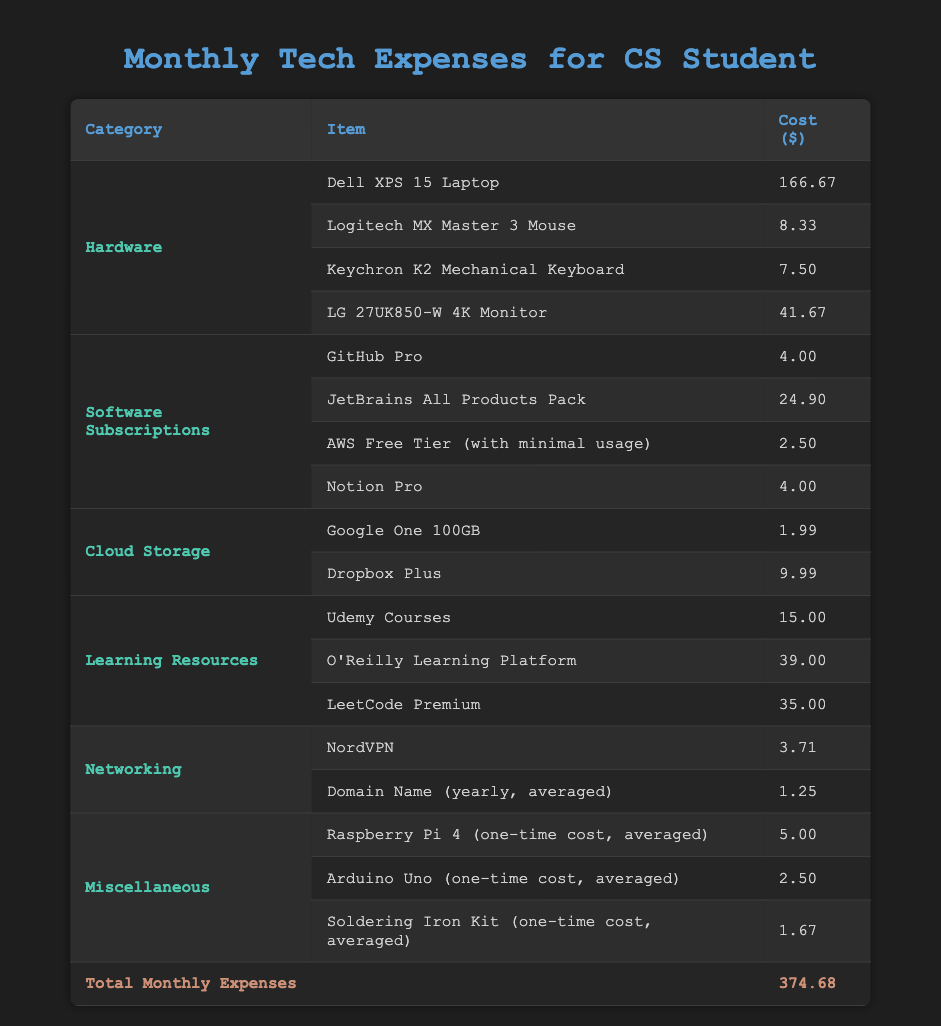What is the total cost of all hardware items? To find the total cost of all hardware items, we add the costs of each item under the 'Hardware' category: 166.67 + 8.33 + 7.50 + 41.67 = 224.17.
Answer: 224.17 How much does the 'JetBrains All Products Pack' cost? The cost for 'JetBrains All Products Pack' is listed in the 'Software Subscriptions' category. It is explicitly stated as 24.90.
Answer: 24.90 Is the monthly expense for 'NordVPN' less than $5? The expense for 'NordVPN' is explicitly stated as 3.71. Since 3.71 is less than 5, the answer is yes.
Answer: Yes What is the total cost for all learning resources? To calculate the total cost for learning resources, we add the costs for: Udemy Courses 15.00, O'Reilly Learning Platform 39.00, and LeetCode Premium 35.00. Their total is 15.00 + 39.00 + 35.00 = 89.00.
Answer: 89.00 How many items are listed under the 'Miscellaneous' category? Under the 'Miscellaneous' category, there are three items listed: Raspberry Pi 4, Arduino Uno, and Soldering Iron Kit. Thus, there are 3 items.
Answer: 3 What percentage of the total expenses is spent on software subscriptions? The total expenses are 374.68, and the total for software subscriptions is: 4.00 + 24.90 + 2.50 + 4.00 = 35.40. To find the percentage, we calculate (35.40 / 374.68) * 100 = 9.45%.
Answer: 9.45 Which category has the highest total cost and what is that amount? We need to calculate the total costs for each category: Hardware is 224.17, Software Subscriptions is 35.40, Cloud Storage is 11.98, Learning Resources is 89.00, Networking is 4.96, and Miscellaneous is 9.17. The highest total is for Hardware at 224.17.
Answer: Hardware, 224.17 How much do the cloud storage items cost in total? The total cost for cloud storage includes: Google One 100GB at 1.99 and Dropbox Plus at 9.99. Adding these gives: 1.99 + 9.99 = 11.98.
Answer: 11.98 Is the combined cost of hardware and cloud storage less than $300? The total for hardware is 224.17 and for cloud storage, it's 11.98. The combined total is 224.17 + 11.98 = 236.15, which is less than 300, hence the answer is yes.
Answer: Yes 